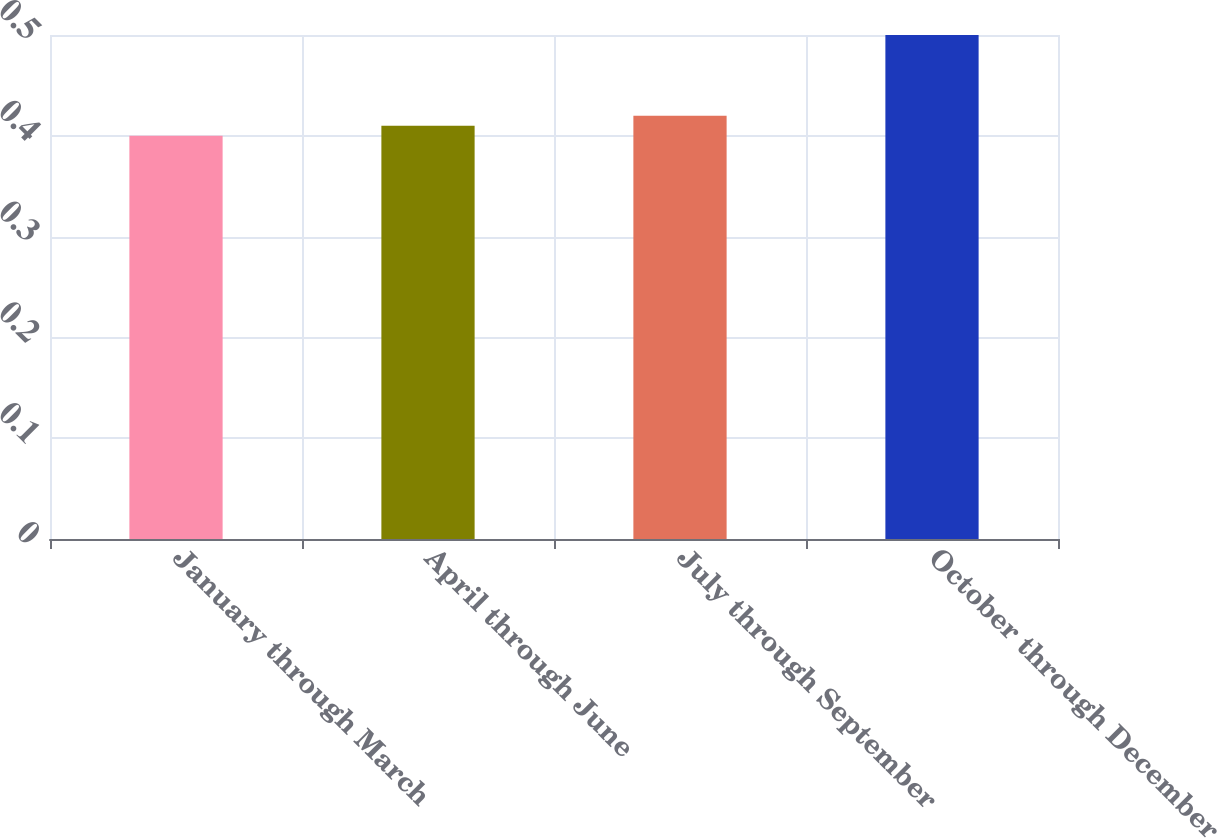Convert chart. <chart><loc_0><loc_0><loc_500><loc_500><bar_chart><fcel>January through March<fcel>April through June<fcel>July through September<fcel>October through December<nl><fcel>0.4<fcel>0.41<fcel>0.42<fcel>0.5<nl></chart> 